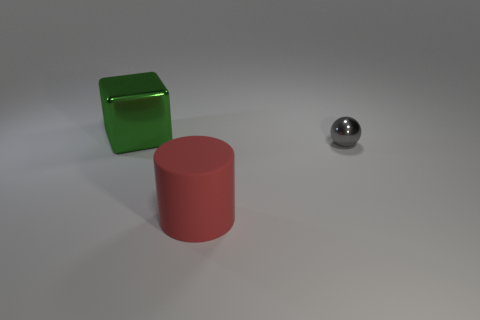Add 3 gray metal spheres. How many objects exist? 6 Subtract all cubes. How many objects are left? 2 Subtract all tiny brown cubes. Subtract all big red rubber things. How many objects are left? 2 Add 2 big metallic cubes. How many big metallic cubes are left? 3 Add 3 big yellow metal cubes. How many big yellow metal cubes exist? 3 Subtract 0 red blocks. How many objects are left? 3 